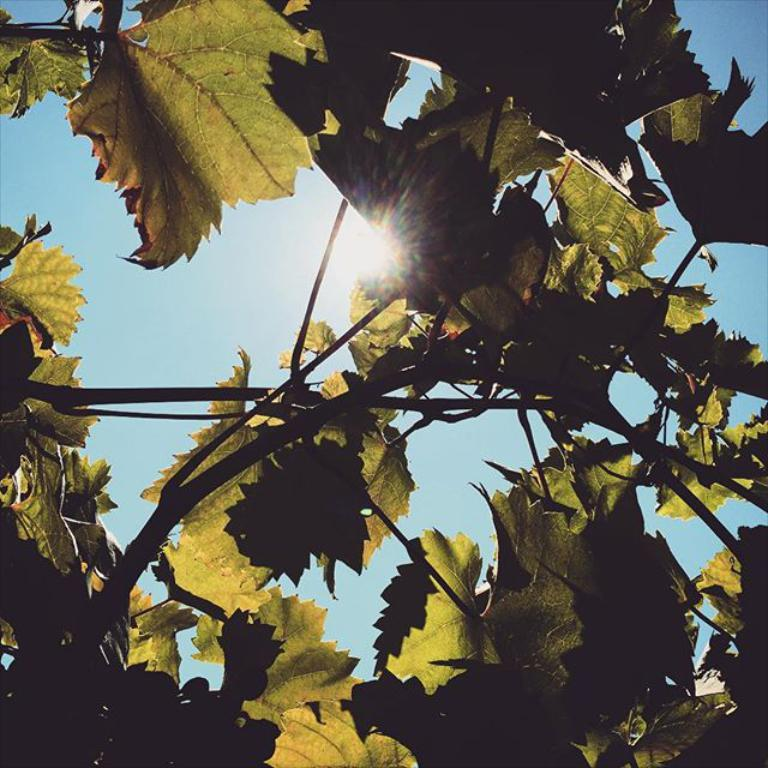What type of vegetation can be seen in the image? There are leaves and branches in the image. What is visible in the background of the image? The sky is visible in the image. Can the sun be seen in the image? Yes, the sun is observable in the sky. How many gloves are hanging from the branches in the image? There are no gloves present in the image; it features leaves and branches. What type of flock is flying across the sky in the image? There is no flock visible in the image; only the sky, sun, leaves, and branches are present. 